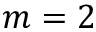Convert formula to latex. <formula><loc_0><loc_0><loc_500><loc_500>m = 2</formula> 